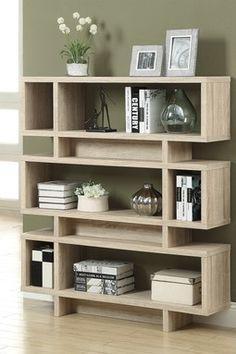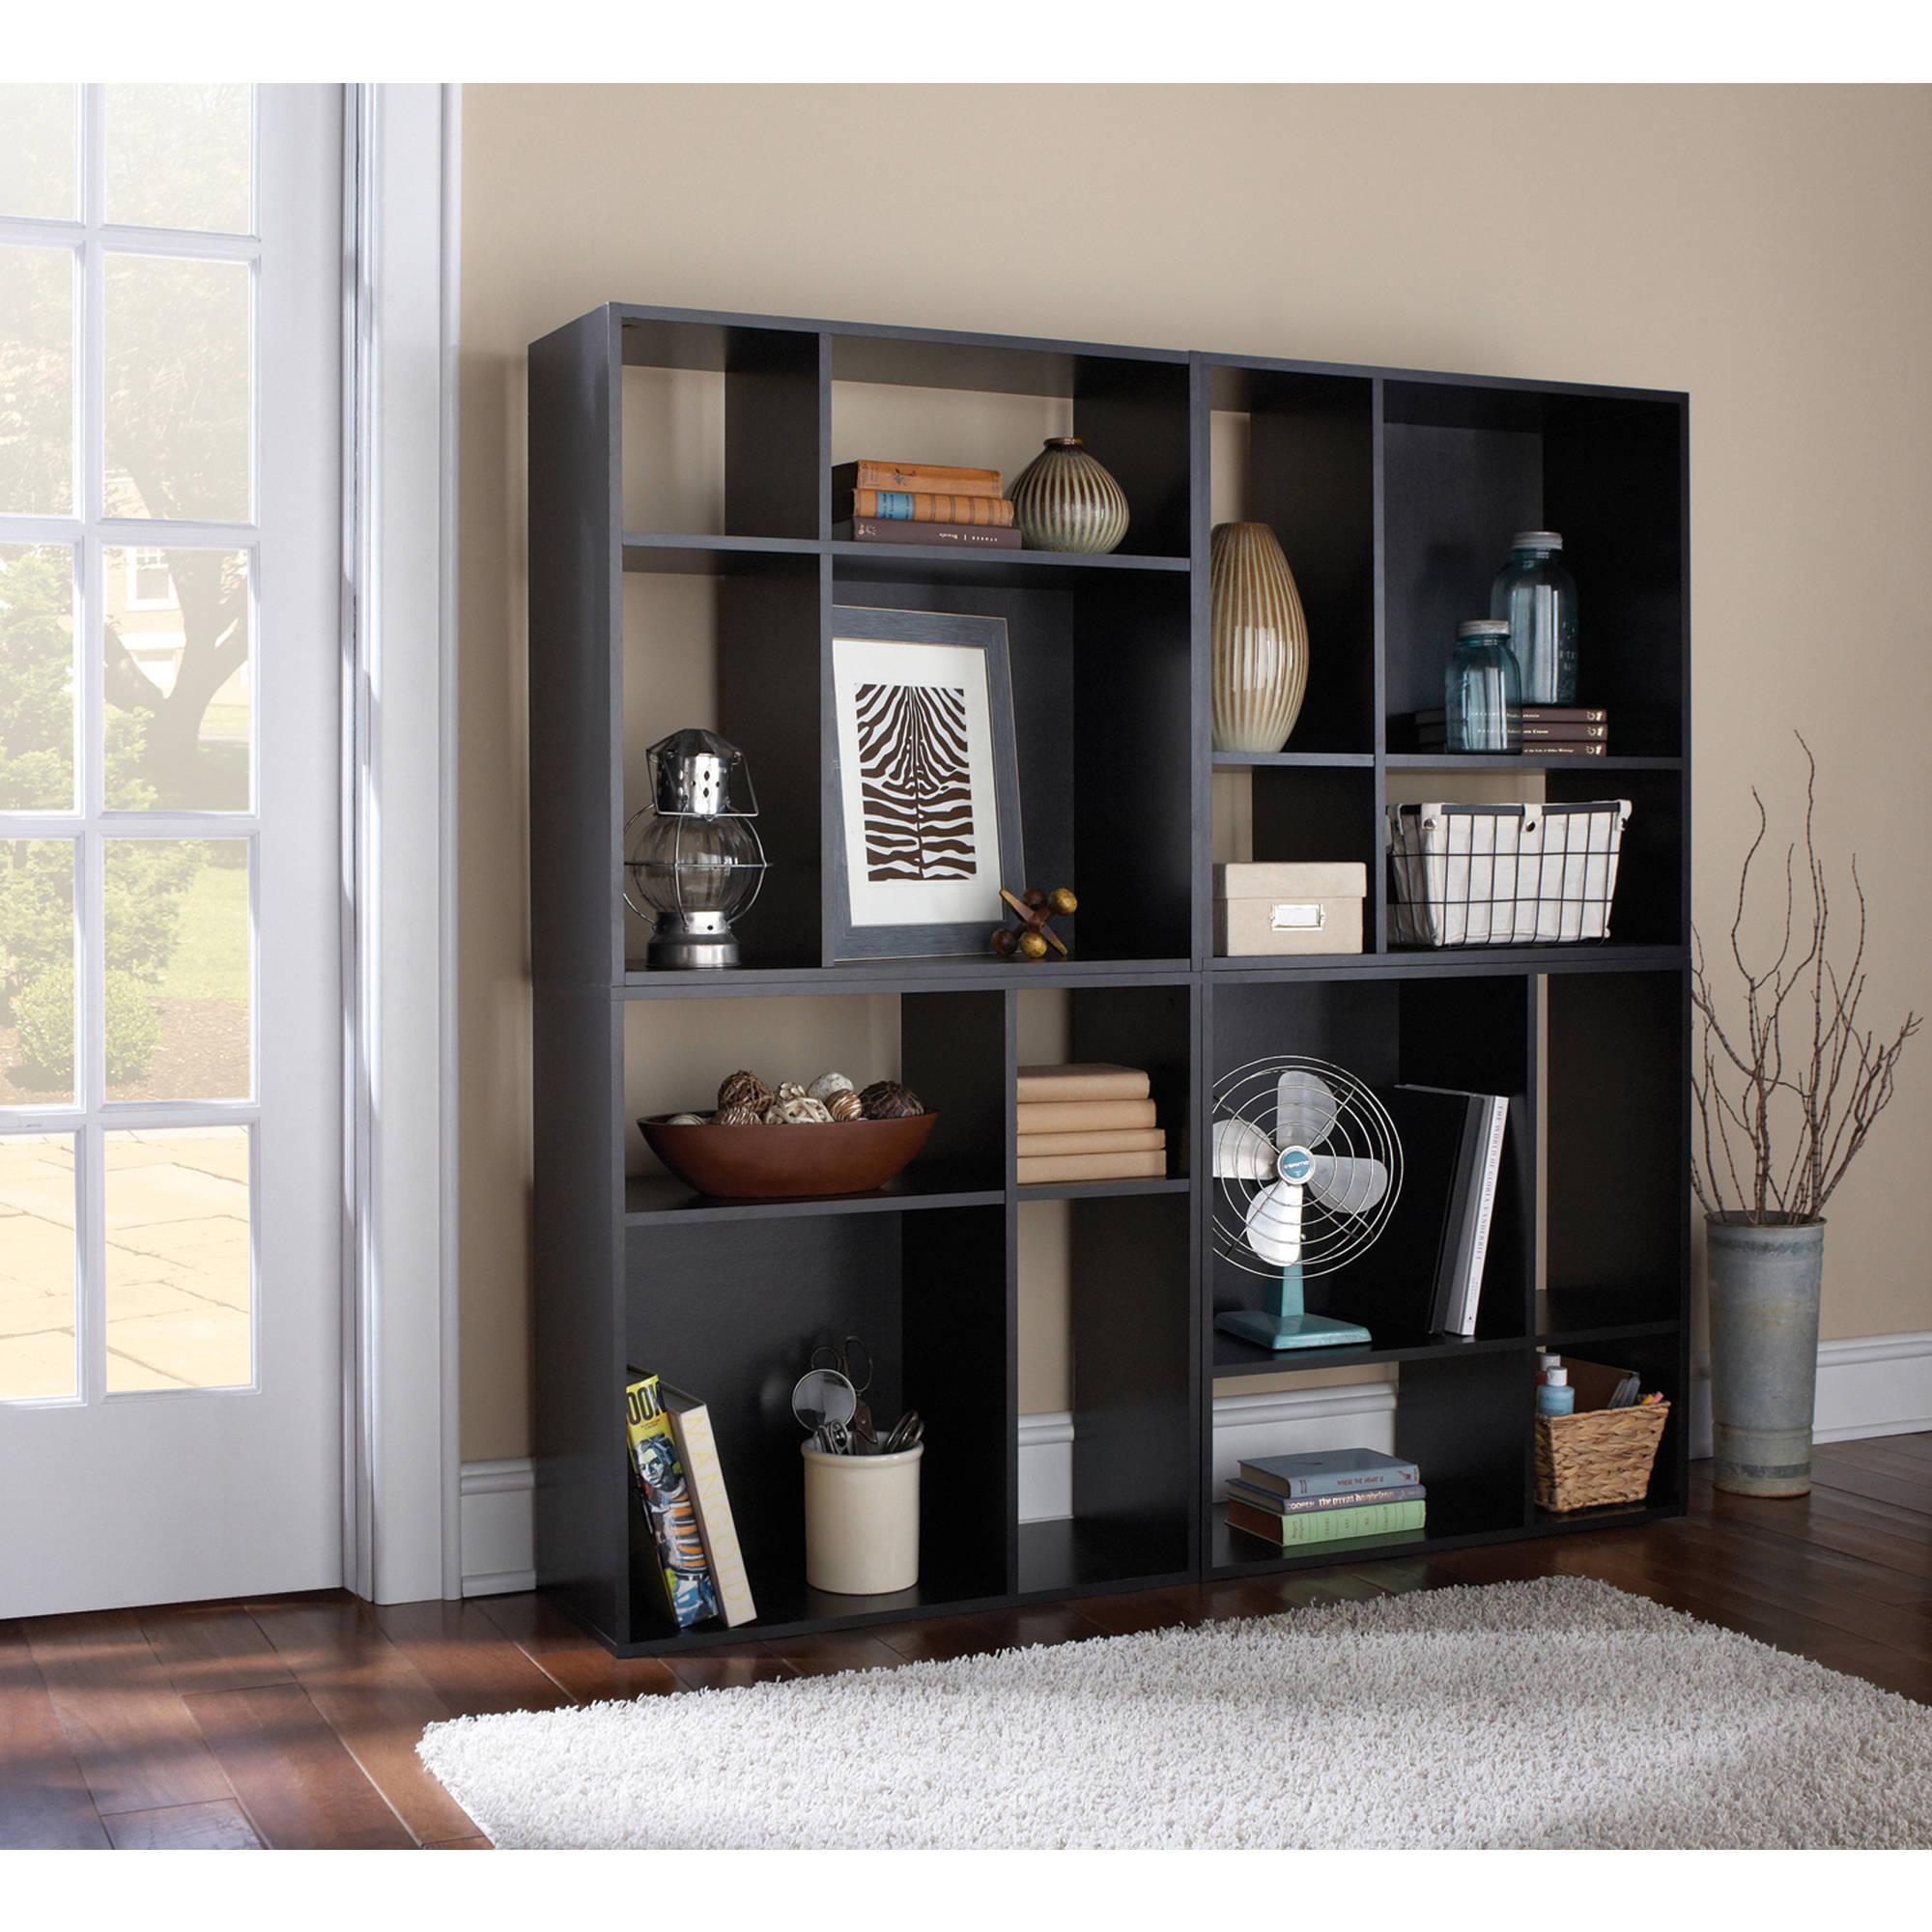The first image is the image on the left, the second image is the image on the right. Assess this claim about the two images: "There is a pot of plant with white flowers on top of a shelf.". Correct or not? Answer yes or no. Yes. The first image is the image on the left, the second image is the image on the right. Evaluate the accuracy of this statement regarding the images: "Exactly one image contains potted flowers.". Is it true? Answer yes or no. Yes. 